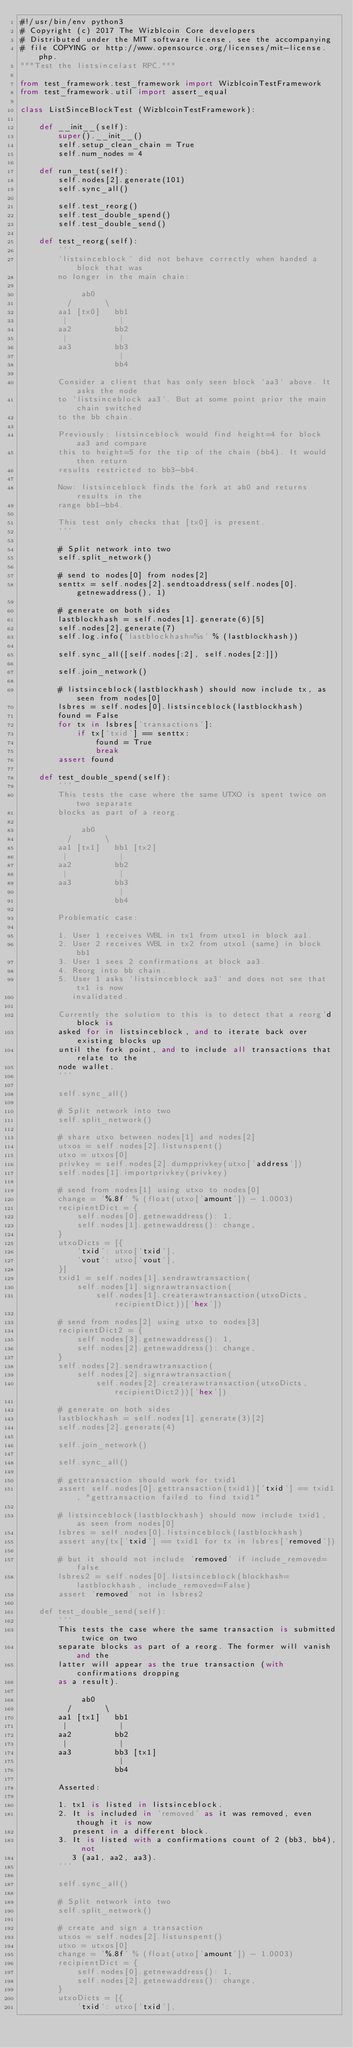<code> <loc_0><loc_0><loc_500><loc_500><_Python_>#!/usr/bin/env python3
# Copyright (c) 2017 The Wizblcoin Core developers
# Distributed under the MIT software license, see the accompanying
# file COPYING or http://www.opensource.org/licenses/mit-license.php.
"""Test the listsincelast RPC."""

from test_framework.test_framework import WizblcoinTestFramework
from test_framework.util import assert_equal

class ListSinceBlockTest (WizblcoinTestFramework):

    def __init__(self):
        super().__init__()
        self.setup_clean_chain = True
        self.num_nodes = 4

    def run_test(self):
        self.nodes[2].generate(101)
        self.sync_all()

        self.test_reorg()
        self.test_double_spend()
        self.test_double_send()

    def test_reorg(self):
        '''
        `listsinceblock` did not behave correctly when handed a block that was
        no longer in the main chain:

             ab0
          /       \
        aa1 [tx0]   bb1
         |           |
        aa2         bb2
         |           |
        aa3         bb3
                     |
                    bb4

        Consider a client that has only seen block `aa3` above. It asks the node
        to `listsinceblock aa3`. But at some point prior the main chain switched
        to the bb chain.

        Previously: listsinceblock would find height=4 for block aa3 and compare
        this to height=5 for the tip of the chain (bb4). It would then return
        results restricted to bb3-bb4.

        Now: listsinceblock finds the fork at ab0 and returns results in the
        range bb1-bb4.

        This test only checks that [tx0] is present.
        '''

        # Split network into two
        self.split_network()

        # send to nodes[0] from nodes[2]
        senttx = self.nodes[2].sendtoaddress(self.nodes[0].getnewaddress(), 1)

        # generate on both sides
        lastblockhash = self.nodes[1].generate(6)[5]
        self.nodes[2].generate(7)
        self.log.info('lastblockhash=%s' % (lastblockhash))

        self.sync_all([self.nodes[:2], self.nodes[2:]])

        self.join_network()

        # listsinceblock(lastblockhash) should now include tx, as seen from nodes[0]
        lsbres = self.nodes[0].listsinceblock(lastblockhash)
        found = False
        for tx in lsbres['transactions']:
            if tx['txid'] == senttx:
                found = True
                break
        assert found

    def test_double_spend(self):
        '''
        This tests the case where the same UTXO is spent twice on two separate
        blocks as part of a reorg.

             ab0
          /       \
        aa1 [tx1]   bb1 [tx2]
         |           |
        aa2         bb2
         |           |
        aa3         bb3
                     |
                    bb4

        Problematic case:

        1. User 1 receives WBL in tx1 from utxo1 in block aa1.
        2. User 2 receives WBL in tx2 from utxo1 (same) in block bb1
        3. User 1 sees 2 confirmations at block aa3.
        4. Reorg into bb chain.
        5. User 1 asks `listsinceblock aa3` and does not see that tx1 is now
           invalidated.

        Currently the solution to this is to detect that a reorg'd block is
        asked for in listsinceblock, and to iterate back over existing blocks up
        until the fork point, and to include all transactions that relate to the
        node wallet.
        '''

        self.sync_all()

        # Split network into two
        self.split_network()

        # share utxo between nodes[1] and nodes[2]
        utxos = self.nodes[2].listunspent()
        utxo = utxos[0]
        privkey = self.nodes[2].dumpprivkey(utxo['address'])
        self.nodes[1].importprivkey(privkey)

        # send from nodes[1] using utxo to nodes[0]
        change = '%.8f' % (float(utxo['amount']) - 1.0003)
        recipientDict = {
            self.nodes[0].getnewaddress(): 1,
            self.nodes[1].getnewaddress(): change,
        }
        utxoDicts = [{
            'txid': utxo['txid'],
            'vout': utxo['vout'],
        }]
        txid1 = self.nodes[1].sendrawtransaction(
            self.nodes[1].signrawtransaction(
                self.nodes[1].createrawtransaction(utxoDicts, recipientDict))['hex'])

        # send from nodes[2] using utxo to nodes[3]
        recipientDict2 = {
            self.nodes[3].getnewaddress(): 1,
            self.nodes[2].getnewaddress(): change,
        }
        self.nodes[2].sendrawtransaction(
            self.nodes[2].signrawtransaction(
                self.nodes[2].createrawtransaction(utxoDicts, recipientDict2))['hex'])

        # generate on both sides
        lastblockhash = self.nodes[1].generate(3)[2]
        self.nodes[2].generate(4)

        self.join_network()

        self.sync_all()

        # gettransaction should work for txid1
        assert self.nodes[0].gettransaction(txid1)['txid'] == txid1, "gettransaction failed to find txid1"

        # listsinceblock(lastblockhash) should now include txid1, as seen from nodes[0]
        lsbres = self.nodes[0].listsinceblock(lastblockhash)
        assert any(tx['txid'] == txid1 for tx in lsbres['removed'])

        # but it should not include 'removed' if include_removed=false
        lsbres2 = self.nodes[0].listsinceblock(blockhash=lastblockhash, include_removed=False)
        assert 'removed' not in lsbres2

    def test_double_send(self):
        '''
        This tests the case where the same transaction is submitted twice on two
        separate blocks as part of a reorg. The former will vanish and the
        latter will appear as the true transaction (with confirmations dropping
        as a result).

             ab0
          /       \
        aa1 [tx1]   bb1
         |           |
        aa2         bb2
         |           |
        aa3         bb3 [tx1]
                     |
                    bb4

        Asserted:

        1. tx1 is listed in listsinceblock.
        2. It is included in 'removed' as it was removed, even though it is now
           present in a different block.
        3. It is listed with a confirmations count of 2 (bb3, bb4), not
           3 (aa1, aa2, aa3).
        '''

        self.sync_all()

        # Split network into two
        self.split_network()

        # create and sign a transaction
        utxos = self.nodes[2].listunspent()
        utxo = utxos[0]
        change = '%.8f' % (float(utxo['amount']) - 1.0003)
        recipientDict = {
            self.nodes[0].getnewaddress(): 1,
            self.nodes[2].getnewaddress(): change,
        }
        utxoDicts = [{
            'txid': utxo['txid'],</code> 